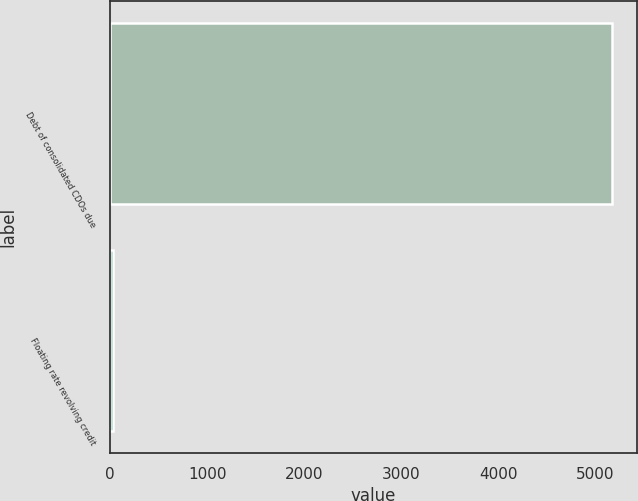<chart> <loc_0><loc_0><loc_500><loc_500><bar_chart><fcel>Debt of consolidated CDOs due<fcel>Floating rate revolving credit<nl><fcel>5171<fcel>28<nl></chart> 